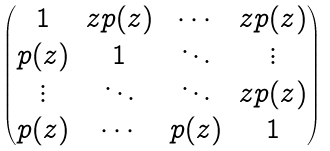Convert formula to latex. <formula><loc_0><loc_0><loc_500><loc_500>\begin{pmatrix} 1 & z p ( z ) & \cdots & z p ( z ) \\ p ( z ) & 1 & \ddots & \vdots \\ \vdots & \ddots & \ddots & z p ( z ) \\ p ( z ) & \cdots & p ( z ) & 1 \end{pmatrix}</formula> 